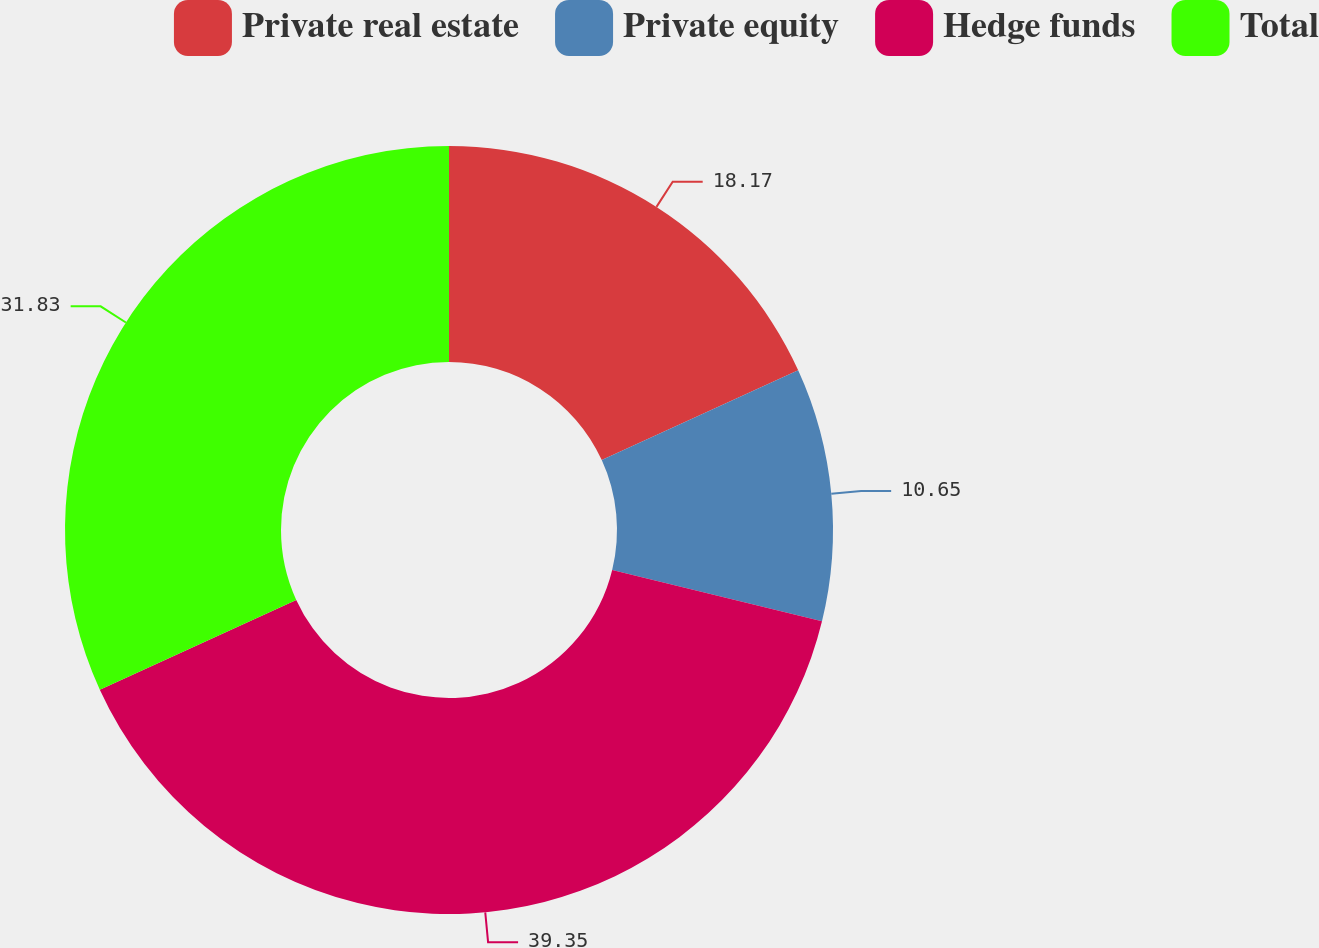Convert chart to OTSL. <chart><loc_0><loc_0><loc_500><loc_500><pie_chart><fcel>Private real estate<fcel>Private equity<fcel>Hedge funds<fcel>Total<nl><fcel>18.17%<fcel>10.65%<fcel>39.35%<fcel>31.83%<nl></chart> 